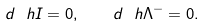<formula> <loc_0><loc_0><loc_500><loc_500>d \ h { I } = 0 , \quad d \ h { \Lambda } ^ { - } = 0 .</formula> 